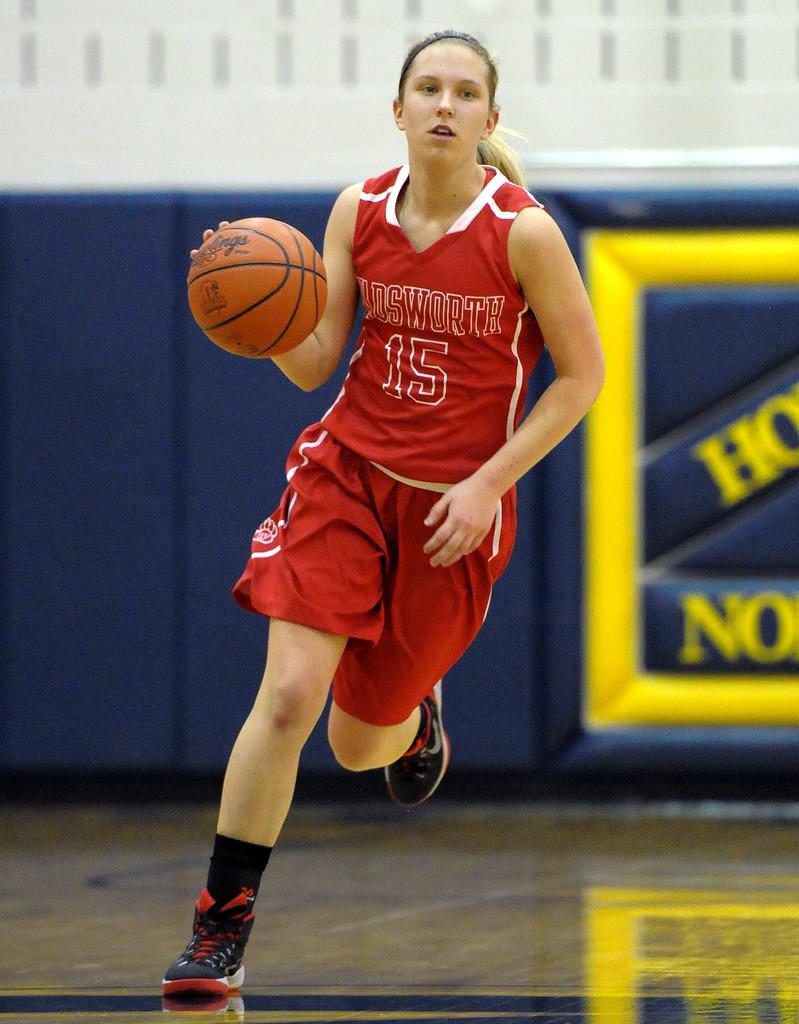<image>
Give a short and clear explanation of the subsequent image. Basketball player wearing a jersey that says Oldsworth on it. 